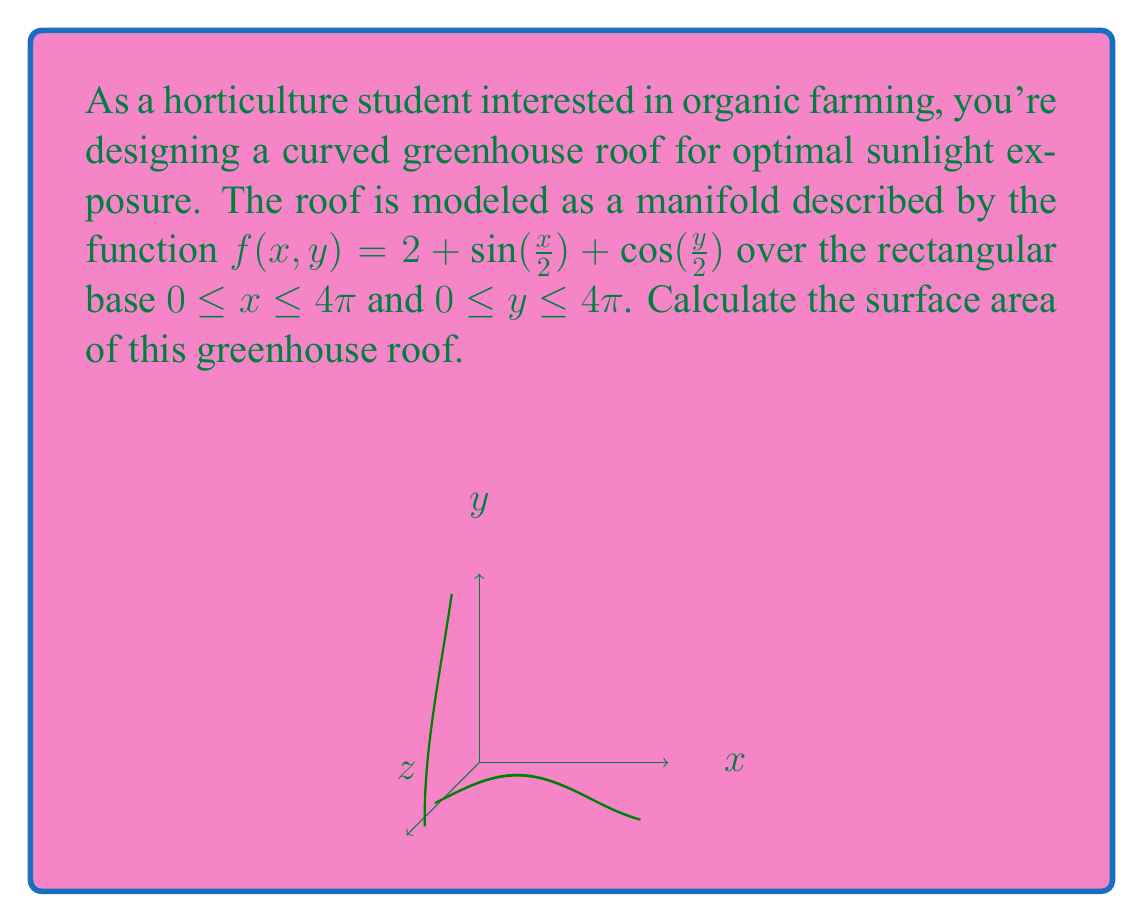Can you answer this question? To calculate the surface area of the curved greenhouse roof, we'll use the surface area formula for a parametric surface:

$$ A = \int\int_R \sqrt{1 + (\frac{\partial f}{\partial x})^2 + (\frac{\partial f}{\partial y})^2} \, dx \, dy $$

Where $R$ is the region over which the surface is defined.

Step 1: Calculate the partial derivatives
$\frac{\partial f}{\partial x} = \frac{1}{2}\cos(\frac{x}{2})$
$\frac{\partial f}{\partial y} = -\frac{1}{2}\sin(\frac{y}{2})$

Step 2: Substitute into the surface area formula
$$ A = \int_0^{4\pi} \int_0^{4\pi} \sqrt{1 + (\frac{1}{2}\cos(\frac{x}{2}))^2 + (-\frac{1}{2}\sin(\frac{y}{2}))^2} \, dx \, dy $$

Step 3: Simplify the integrand
$$ A = \int_0^{4\pi} \int_0^{4\pi} \sqrt{1 + \frac{1}{4}\cos^2(\frac{x}{2}) + \frac{1}{4}\sin^2(\frac{y}{2})} \, dx \, dy $$

Step 4: This integral cannot be evaluated analytically, so we need to use numerical integration methods. Using a computer algebra system or numerical integration tool, we can approximate the result:

$$ A \approx 66.77 \, \text{square units} $$
Answer: $66.77 \, \text{square units}$ 